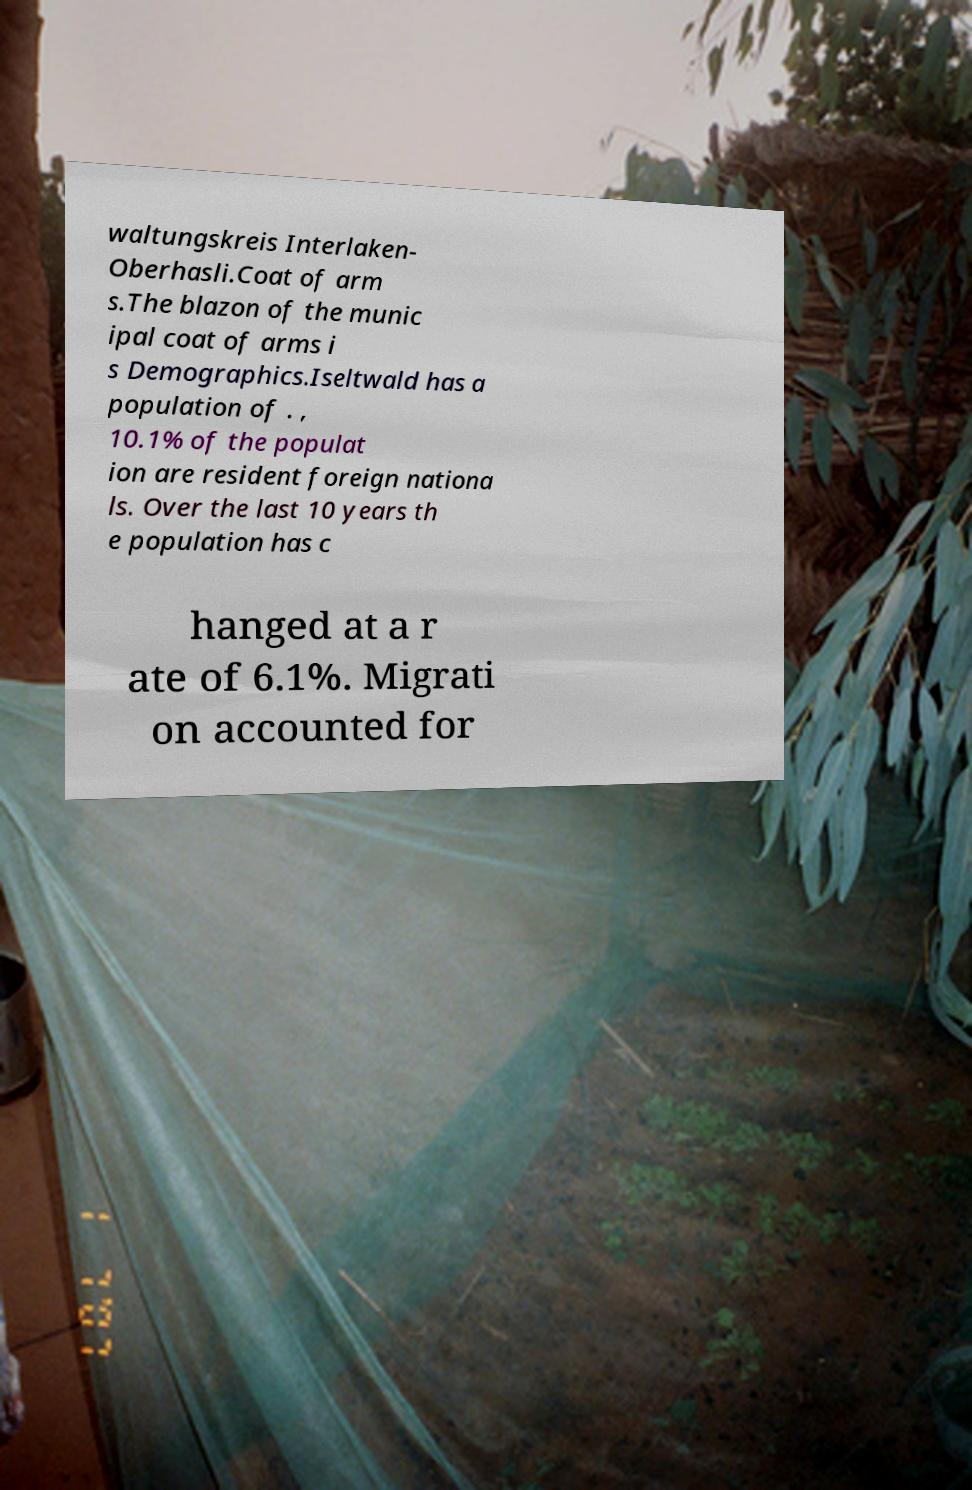Please identify and transcribe the text found in this image. waltungskreis Interlaken- Oberhasli.Coat of arm s.The blazon of the munic ipal coat of arms i s Demographics.Iseltwald has a population of . , 10.1% of the populat ion are resident foreign nationa ls. Over the last 10 years th e population has c hanged at a r ate of 6.1%. Migrati on accounted for 